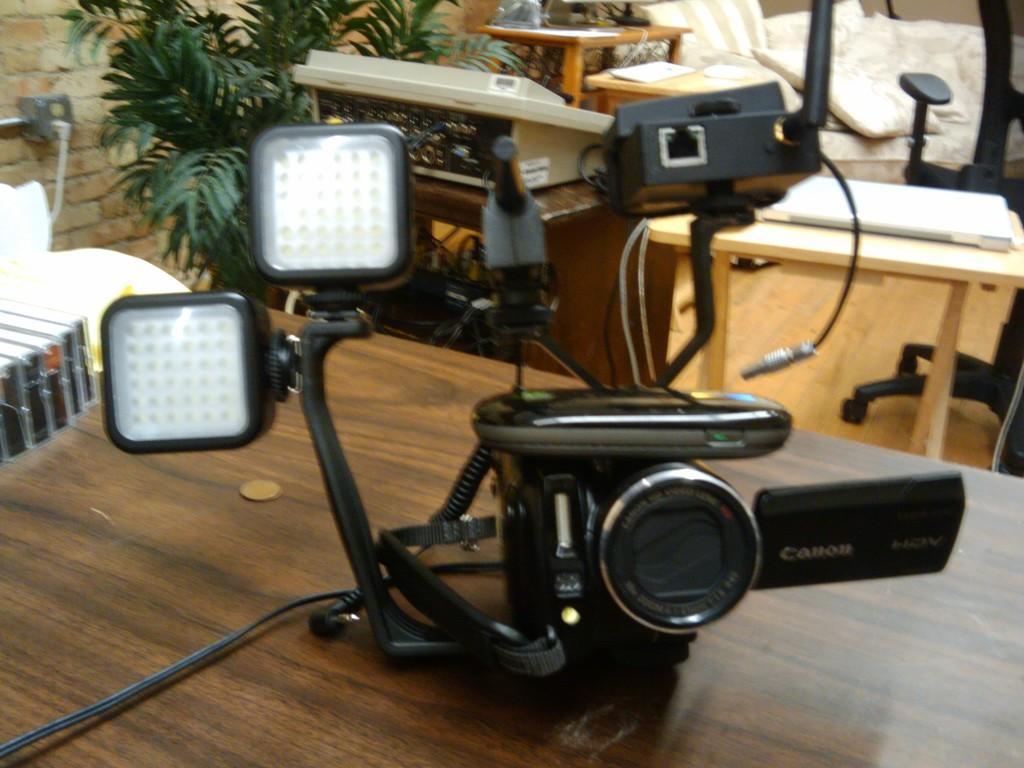Could you give a brief overview of what you see in this image? In this image on the table there is a camera with the name written canon. In the background there is a chair, table, plants and wall. 